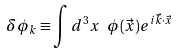Convert formula to latex. <formula><loc_0><loc_0><loc_500><loc_500>\delta \phi _ { k } \equiv \int d ^ { 3 } x \ \phi ( \vec { x } ) e ^ { i \vec { k } \cdot \vec { x } }</formula> 